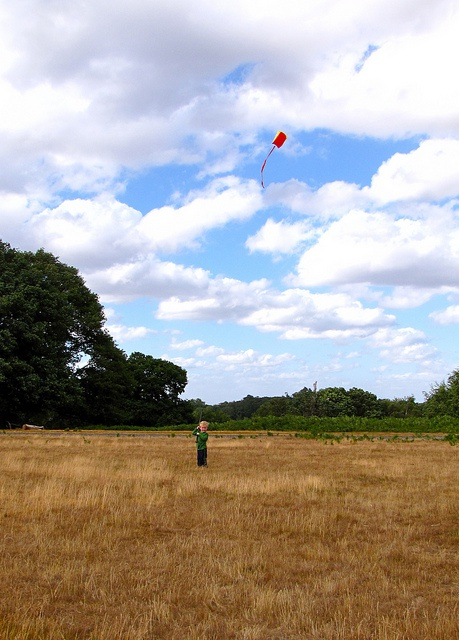Describe the objects in this image and their specific colors. I can see people in white, black, darkgreen, and brown tones and kite in white, brown, and lightblue tones in this image. 